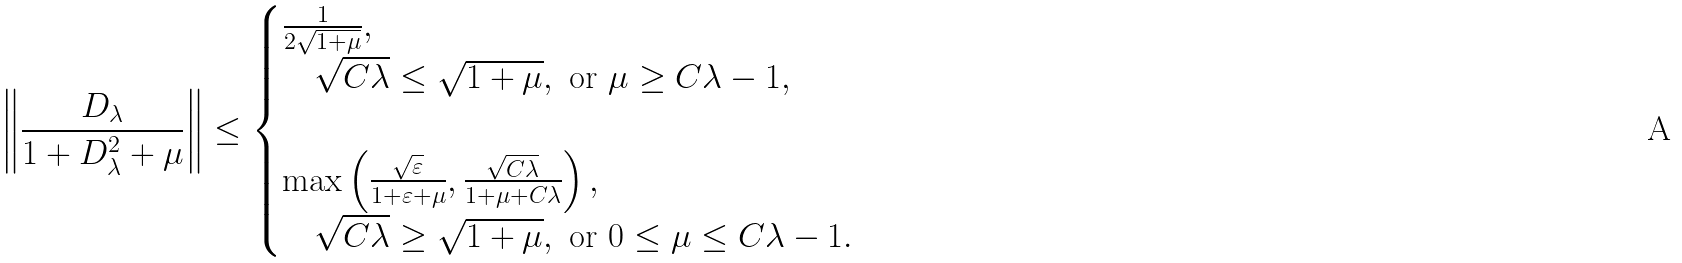Convert formula to latex. <formula><loc_0><loc_0><loc_500><loc_500>\left \| \frac { D _ { \lambda } } { 1 + D _ { \lambda } ^ { 2 } + \mu } \right \| \leq \begin{cases} \frac { 1 } { 2 \sqrt { 1 + \mu } } , & \\ \quad \sqrt { C \lambda } \leq \sqrt { 1 + \mu } , \text { or } \mu \geq C \lambda - 1 , \\ & \\ \max \left ( \frac { \sqrt { \varepsilon } } { 1 + \varepsilon + \mu } , \frac { \sqrt { C \lambda } } { 1 + \mu + C \lambda } \right ) , & \\ \quad \sqrt { C \lambda } \geq \sqrt { 1 + \mu } , \text { or } 0 \leq \mu \leq C \lambda - 1 . & \end{cases}</formula> 